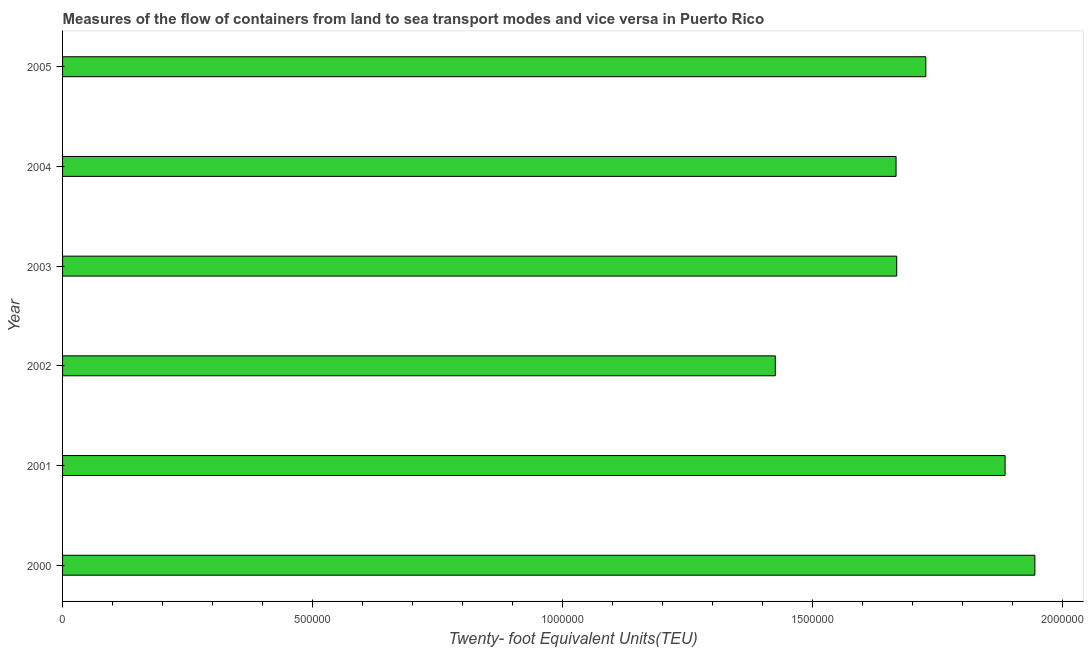What is the title of the graph?
Your answer should be very brief. Measures of the flow of containers from land to sea transport modes and vice versa in Puerto Rico. What is the label or title of the X-axis?
Make the answer very short. Twenty- foot Equivalent Units(TEU). What is the label or title of the Y-axis?
Your answer should be compact. Year. What is the container port traffic in 2000?
Offer a terse response. 1.95e+06. Across all years, what is the maximum container port traffic?
Your answer should be compact. 1.95e+06. Across all years, what is the minimum container port traffic?
Offer a terse response. 1.43e+06. In which year was the container port traffic minimum?
Provide a short and direct response. 2002. What is the sum of the container port traffic?
Offer a very short reply. 1.03e+07. What is the difference between the container port traffic in 2002 and 2003?
Make the answer very short. -2.43e+05. What is the average container port traffic per year?
Give a very brief answer. 1.72e+06. What is the median container port traffic?
Your response must be concise. 1.70e+06. Do a majority of the years between 2002 and 2000 (inclusive) have container port traffic greater than 600000 TEU?
Keep it short and to the point. Yes. What is the ratio of the container port traffic in 2000 to that in 2005?
Offer a terse response. 1.13. Is the container port traffic in 2001 less than that in 2002?
Your answer should be compact. No. What is the difference between the highest and the second highest container port traffic?
Provide a succinct answer. 5.96e+04. Is the sum of the container port traffic in 2002 and 2005 greater than the maximum container port traffic across all years?
Provide a short and direct response. Yes. What is the difference between the highest and the lowest container port traffic?
Make the answer very short. 5.19e+05. How many bars are there?
Your response must be concise. 6. What is the Twenty- foot Equivalent Units(TEU) in 2000?
Your answer should be compact. 1.95e+06. What is the Twenty- foot Equivalent Units(TEU) in 2001?
Provide a short and direct response. 1.89e+06. What is the Twenty- foot Equivalent Units(TEU) of 2002?
Provide a succinct answer. 1.43e+06. What is the Twenty- foot Equivalent Units(TEU) in 2003?
Offer a terse response. 1.67e+06. What is the Twenty- foot Equivalent Units(TEU) of 2004?
Offer a terse response. 1.67e+06. What is the Twenty- foot Equivalent Units(TEU) of 2005?
Give a very brief answer. 1.73e+06. What is the difference between the Twenty- foot Equivalent Units(TEU) in 2000 and 2001?
Make the answer very short. 5.96e+04. What is the difference between the Twenty- foot Equivalent Units(TEU) in 2000 and 2002?
Your response must be concise. 5.19e+05. What is the difference between the Twenty- foot Equivalent Units(TEU) in 2000 and 2003?
Offer a terse response. 2.76e+05. What is the difference between the Twenty- foot Equivalent Units(TEU) in 2000 and 2004?
Your answer should be compact. 2.78e+05. What is the difference between the Twenty- foot Equivalent Units(TEU) in 2000 and 2005?
Your answer should be very brief. 2.18e+05. What is the difference between the Twenty- foot Equivalent Units(TEU) in 2001 and 2002?
Offer a terse response. 4.60e+05. What is the difference between the Twenty- foot Equivalent Units(TEU) in 2001 and 2003?
Offer a very short reply. 2.17e+05. What is the difference between the Twenty- foot Equivalent Units(TEU) in 2001 and 2004?
Ensure brevity in your answer.  2.18e+05. What is the difference between the Twenty- foot Equivalent Units(TEU) in 2001 and 2005?
Your response must be concise. 1.59e+05. What is the difference between the Twenty- foot Equivalent Units(TEU) in 2002 and 2003?
Your answer should be very brief. -2.43e+05. What is the difference between the Twenty- foot Equivalent Units(TEU) in 2002 and 2004?
Your answer should be very brief. -2.42e+05. What is the difference between the Twenty- foot Equivalent Units(TEU) in 2002 and 2005?
Your response must be concise. -3.01e+05. What is the difference between the Twenty- foot Equivalent Units(TEU) in 2003 and 2004?
Your response must be concise. 1302. What is the difference between the Twenty- foot Equivalent Units(TEU) in 2003 and 2005?
Your answer should be compact. -5.82e+04. What is the difference between the Twenty- foot Equivalent Units(TEU) in 2004 and 2005?
Offer a very short reply. -5.95e+04. What is the ratio of the Twenty- foot Equivalent Units(TEU) in 2000 to that in 2001?
Give a very brief answer. 1.03. What is the ratio of the Twenty- foot Equivalent Units(TEU) in 2000 to that in 2002?
Provide a succinct answer. 1.36. What is the ratio of the Twenty- foot Equivalent Units(TEU) in 2000 to that in 2003?
Give a very brief answer. 1.17. What is the ratio of the Twenty- foot Equivalent Units(TEU) in 2000 to that in 2004?
Give a very brief answer. 1.17. What is the ratio of the Twenty- foot Equivalent Units(TEU) in 2000 to that in 2005?
Your response must be concise. 1.13. What is the ratio of the Twenty- foot Equivalent Units(TEU) in 2001 to that in 2002?
Your response must be concise. 1.32. What is the ratio of the Twenty- foot Equivalent Units(TEU) in 2001 to that in 2003?
Keep it short and to the point. 1.13. What is the ratio of the Twenty- foot Equivalent Units(TEU) in 2001 to that in 2004?
Offer a terse response. 1.13. What is the ratio of the Twenty- foot Equivalent Units(TEU) in 2001 to that in 2005?
Make the answer very short. 1.09. What is the ratio of the Twenty- foot Equivalent Units(TEU) in 2002 to that in 2003?
Give a very brief answer. 0.85. What is the ratio of the Twenty- foot Equivalent Units(TEU) in 2002 to that in 2004?
Your answer should be compact. 0.85. What is the ratio of the Twenty- foot Equivalent Units(TEU) in 2002 to that in 2005?
Your answer should be very brief. 0.83. What is the ratio of the Twenty- foot Equivalent Units(TEU) in 2003 to that in 2004?
Your answer should be compact. 1. 